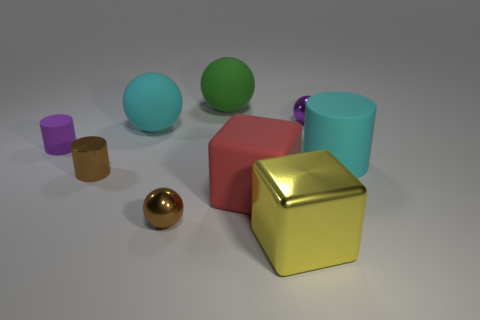Subtract all small purple shiny spheres. How many spheres are left? 3 Add 1 gray cylinders. How many objects exist? 10 Subtract all cyan cylinders. How many cylinders are left? 2 Subtract all cylinders. How many objects are left? 6 Subtract all yellow cylinders. Subtract all cyan cubes. How many cylinders are left? 3 Subtract all cyan balls. Subtract all small purple matte objects. How many objects are left? 7 Add 8 big rubber cylinders. How many big rubber cylinders are left? 9 Add 1 small brown metallic cylinders. How many small brown metallic cylinders exist? 2 Subtract 0 purple blocks. How many objects are left? 9 